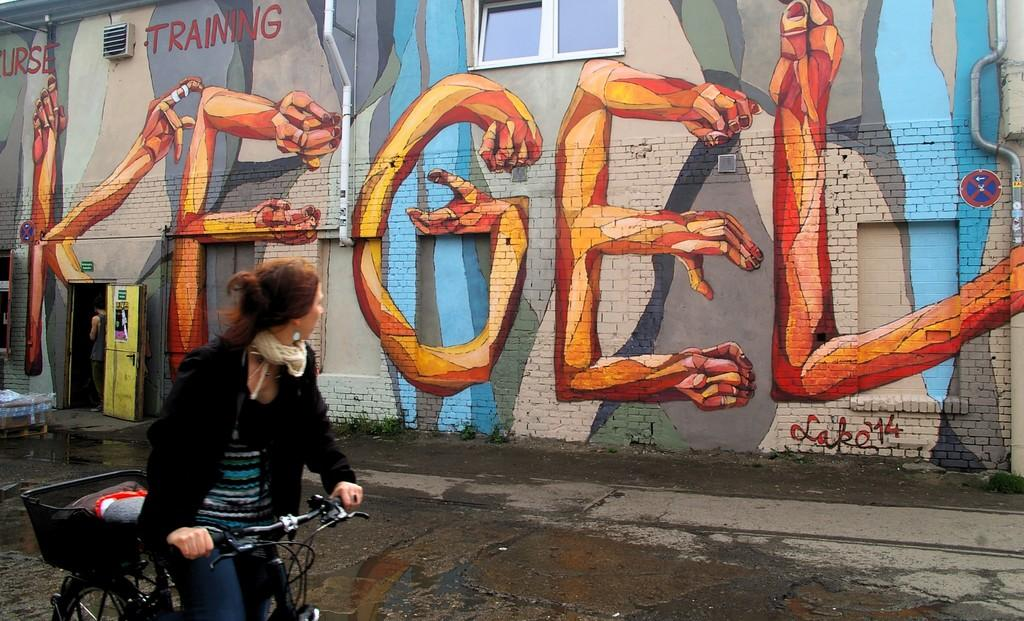What is a prominent feature of the image? There is a wall in the image. What can be found on the wall? There is a door in the wall. Who is present in the image? A man is standing in the image, and a woman is riding a bicycle. What type of bucket is the boy carrying in the image? There is no boy or bucket present in the image. 